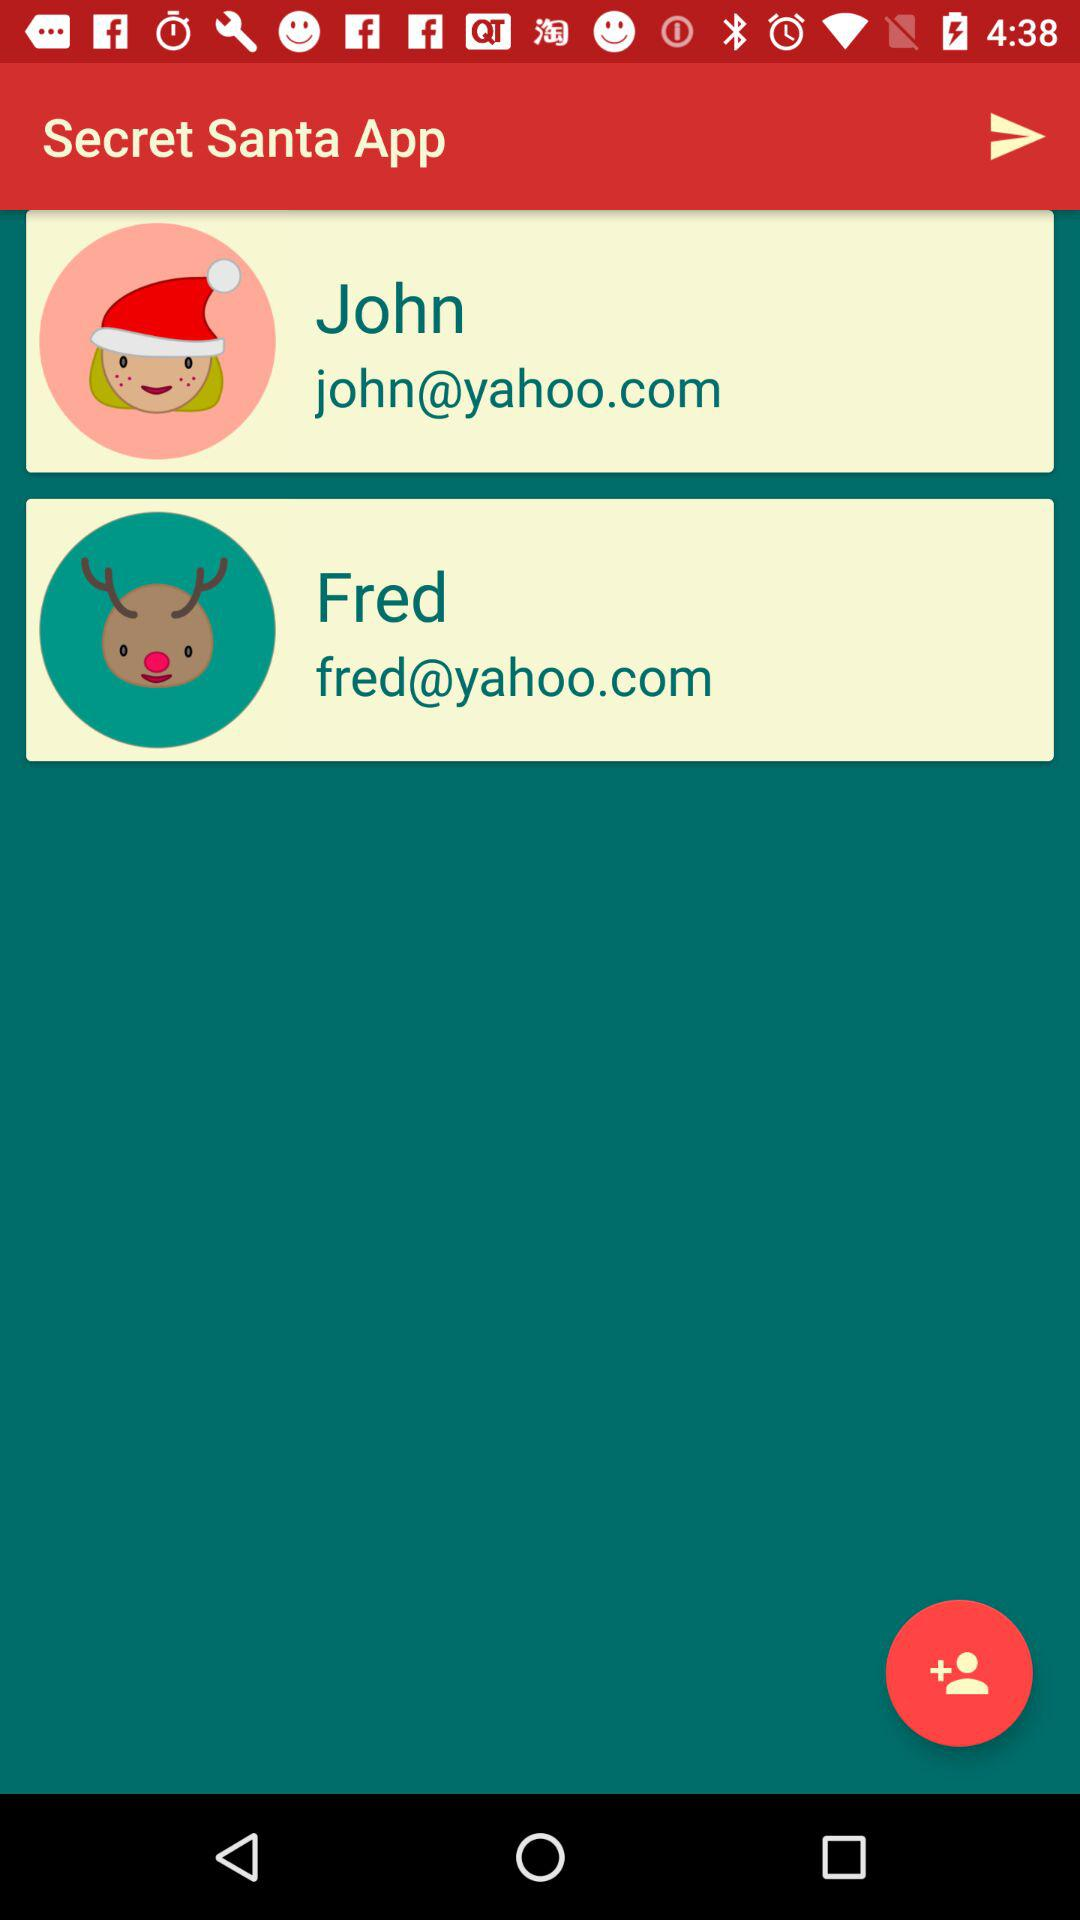What's John's Yahoo email address? John's Yahoo email address is john@yahoo.com. 